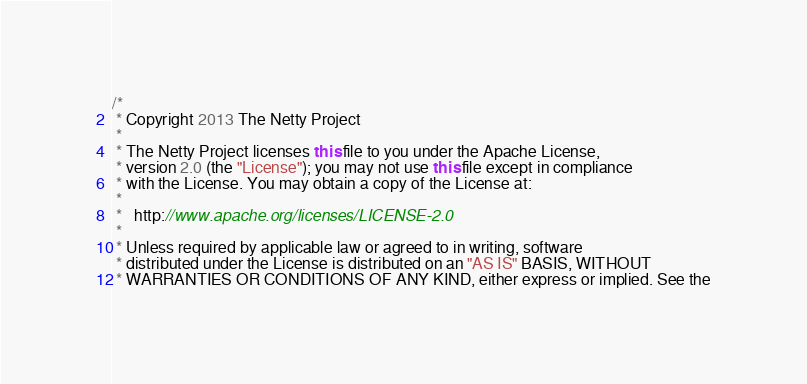Convert code to text. <code><loc_0><loc_0><loc_500><loc_500><_Java_>/*
 * Copyright 2013 The Netty Project
 *
 * The Netty Project licenses this file to you under the Apache License,
 * version 2.0 (the "License"); you may not use this file except in compliance
 * with the License. You may obtain a copy of the License at:
 *
 *   http://www.apache.org/licenses/LICENSE-2.0
 *
 * Unless required by applicable law or agreed to in writing, software
 * distributed under the License is distributed on an "AS IS" BASIS, WITHOUT
 * WARRANTIES OR CONDITIONS OF ANY KIND, either express or implied. See the</code> 